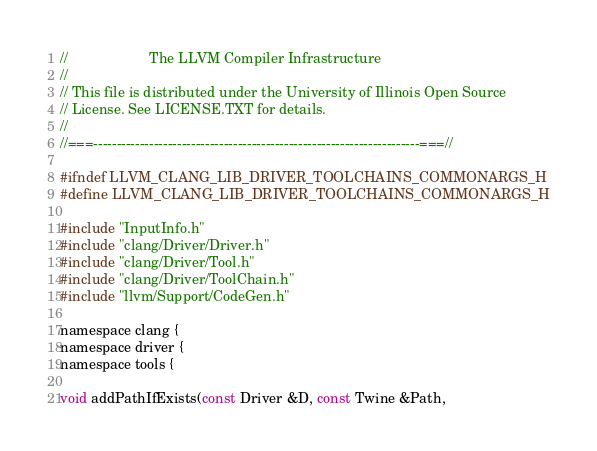Convert code to text. <code><loc_0><loc_0><loc_500><loc_500><_C_>//                     The LLVM Compiler Infrastructure
//
// This file is distributed under the University of Illinois Open Source
// License. See LICENSE.TXT for details.
//
//===----------------------------------------------------------------------===//

#ifndef LLVM_CLANG_LIB_DRIVER_TOOLCHAINS_COMMONARGS_H
#define LLVM_CLANG_LIB_DRIVER_TOOLCHAINS_COMMONARGS_H

#include "InputInfo.h"
#include "clang/Driver/Driver.h"
#include "clang/Driver/Tool.h"
#include "clang/Driver/ToolChain.h"
#include "llvm/Support/CodeGen.h"

namespace clang {
namespace driver {
namespace tools {

void addPathIfExists(const Driver &D, const Twine &Path,</code> 